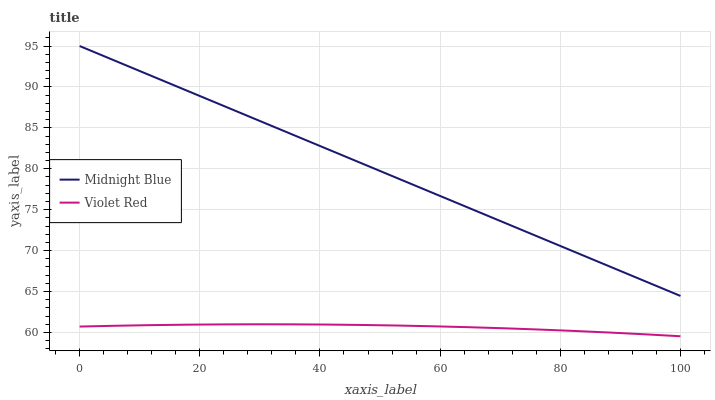Does Violet Red have the minimum area under the curve?
Answer yes or no. Yes. Does Midnight Blue have the maximum area under the curve?
Answer yes or no. Yes. Does Midnight Blue have the minimum area under the curve?
Answer yes or no. No. Is Midnight Blue the smoothest?
Answer yes or no. Yes. Is Violet Red the roughest?
Answer yes or no. Yes. Is Midnight Blue the roughest?
Answer yes or no. No. Does Violet Red have the lowest value?
Answer yes or no. Yes. Does Midnight Blue have the lowest value?
Answer yes or no. No. Does Midnight Blue have the highest value?
Answer yes or no. Yes. Is Violet Red less than Midnight Blue?
Answer yes or no. Yes. Is Midnight Blue greater than Violet Red?
Answer yes or no. Yes. Does Violet Red intersect Midnight Blue?
Answer yes or no. No. 